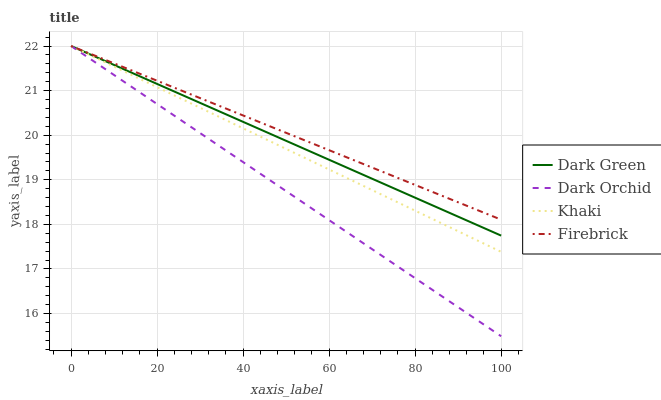Does Dark Orchid have the minimum area under the curve?
Answer yes or no. Yes. Does Firebrick have the maximum area under the curve?
Answer yes or no. Yes. Does Khaki have the minimum area under the curve?
Answer yes or no. No. Does Khaki have the maximum area under the curve?
Answer yes or no. No. Is Dark Orchid the smoothest?
Answer yes or no. Yes. Is Khaki the roughest?
Answer yes or no. Yes. Is Khaki the smoothest?
Answer yes or no. No. Is Dark Orchid the roughest?
Answer yes or no. No. Does Dark Orchid have the lowest value?
Answer yes or no. Yes. Does Khaki have the lowest value?
Answer yes or no. No. Does Dark Green have the highest value?
Answer yes or no. Yes. Does Khaki intersect Firebrick?
Answer yes or no. Yes. Is Khaki less than Firebrick?
Answer yes or no. No. Is Khaki greater than Firebrick?
Answer yes or no. No. 